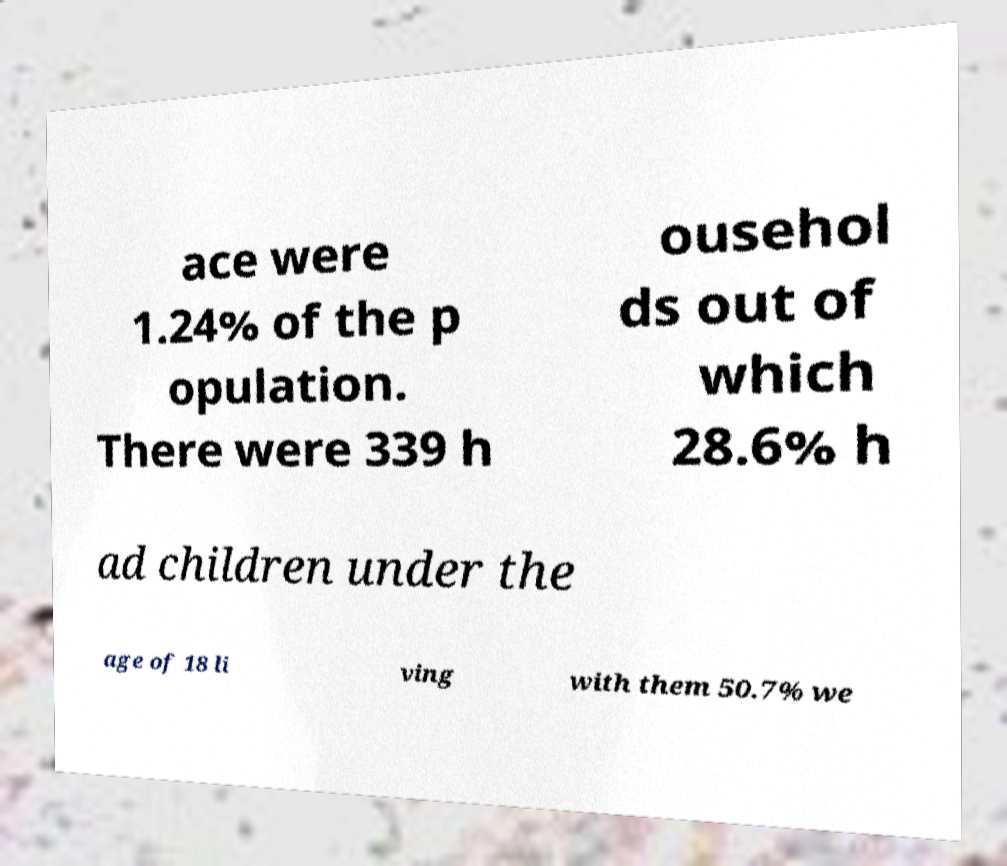Can you accurately transcribe the text from the provided image for me? ace were 1.24% of the p opulation. There were 339 h ousehol ds out of which 28.6% h ad children under the age of 18 li ving with them 50.7% we 